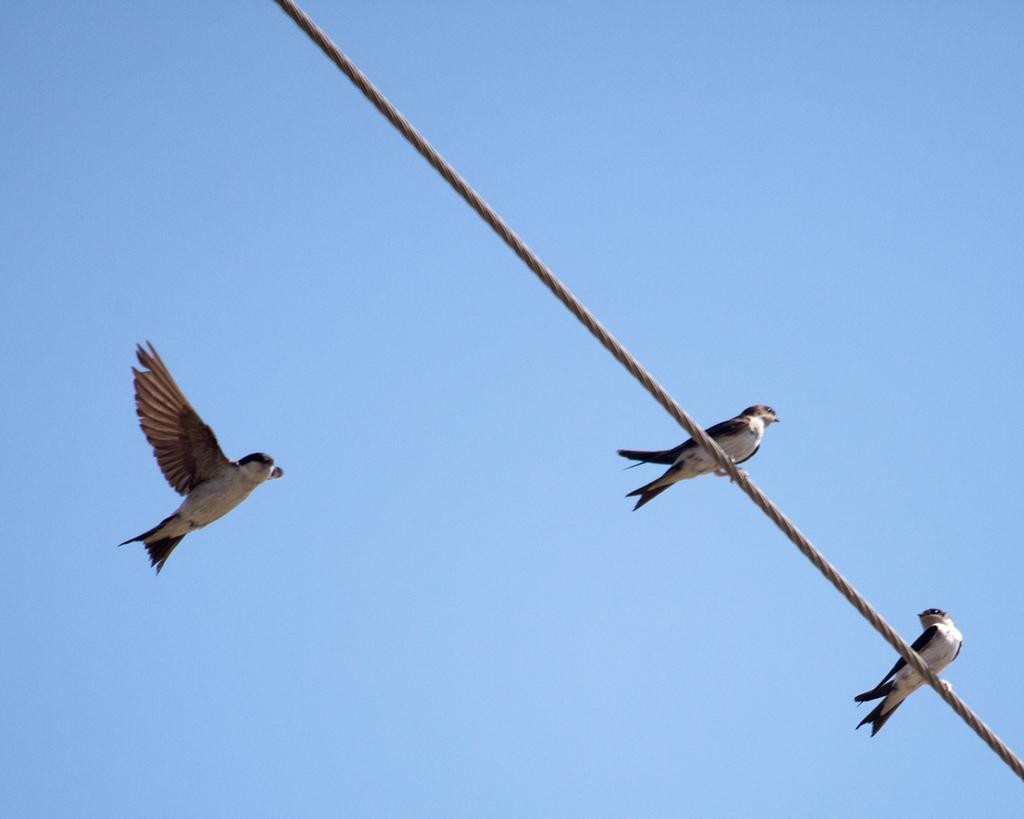What type of animals can be seen in the image? There are birds in the image. What is the birds' location in relation to the wire? The wire is in the image, but the specific location of the birds in relation to the wire is not mentioned. What can be seen in the background of the image? The sky is visible in the background of the image. What advice does the maid give to the birds in the image? There is no maid present in the image, so no advice can be given. 